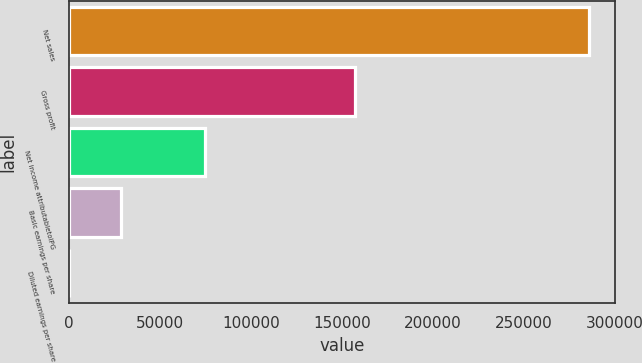<chart> <loc_0><loc_0><loc_500><loc_500><bar_chart><fcel>Net sales<fcel>Gross profit<fcel>Net income attributabletoIPG<fcel>Basic earnings per share<fcel>Diluted earnings per share<nl><fcel>285846<fcel>157267<fcel>74945<fcel>28585.8<fcel>1.38<nl></chart> 